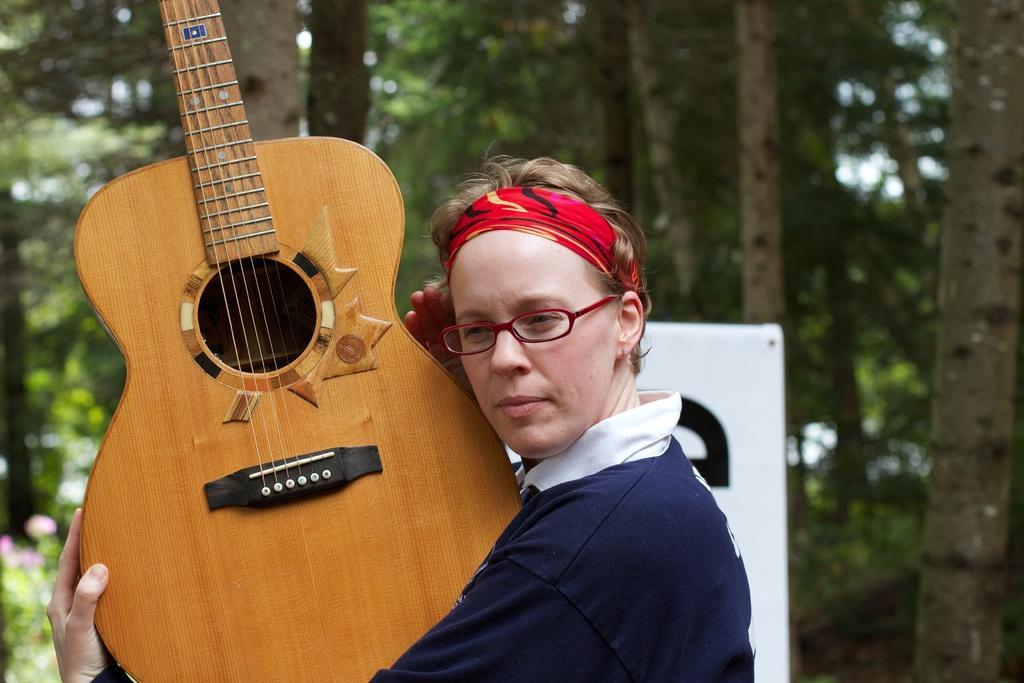Please provide a concise description of this image. Person holding guitar,in the background there are trees. 